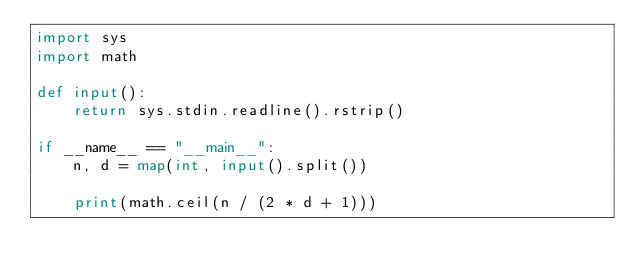Convert code to text. <code><loc_0><loc_0><loc_500><loc_500><_Python_>import sys
import math

def input():
    return sys.stdin.readline().rstrip()

if __name__ == "__main__":
    n, d = map(int, input().split())

    print(math.ceil(n / (2 * d + 1)))
</code> 